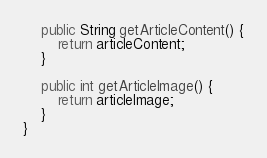Convert code to text. <code><loc_0><loc_0><loc_500><loc_500><_Java_>
    public String getArticleContent() {
        return articleContent;
    }

    public int getArticleImage() {
        return articleImage;
    }
}
</code> 